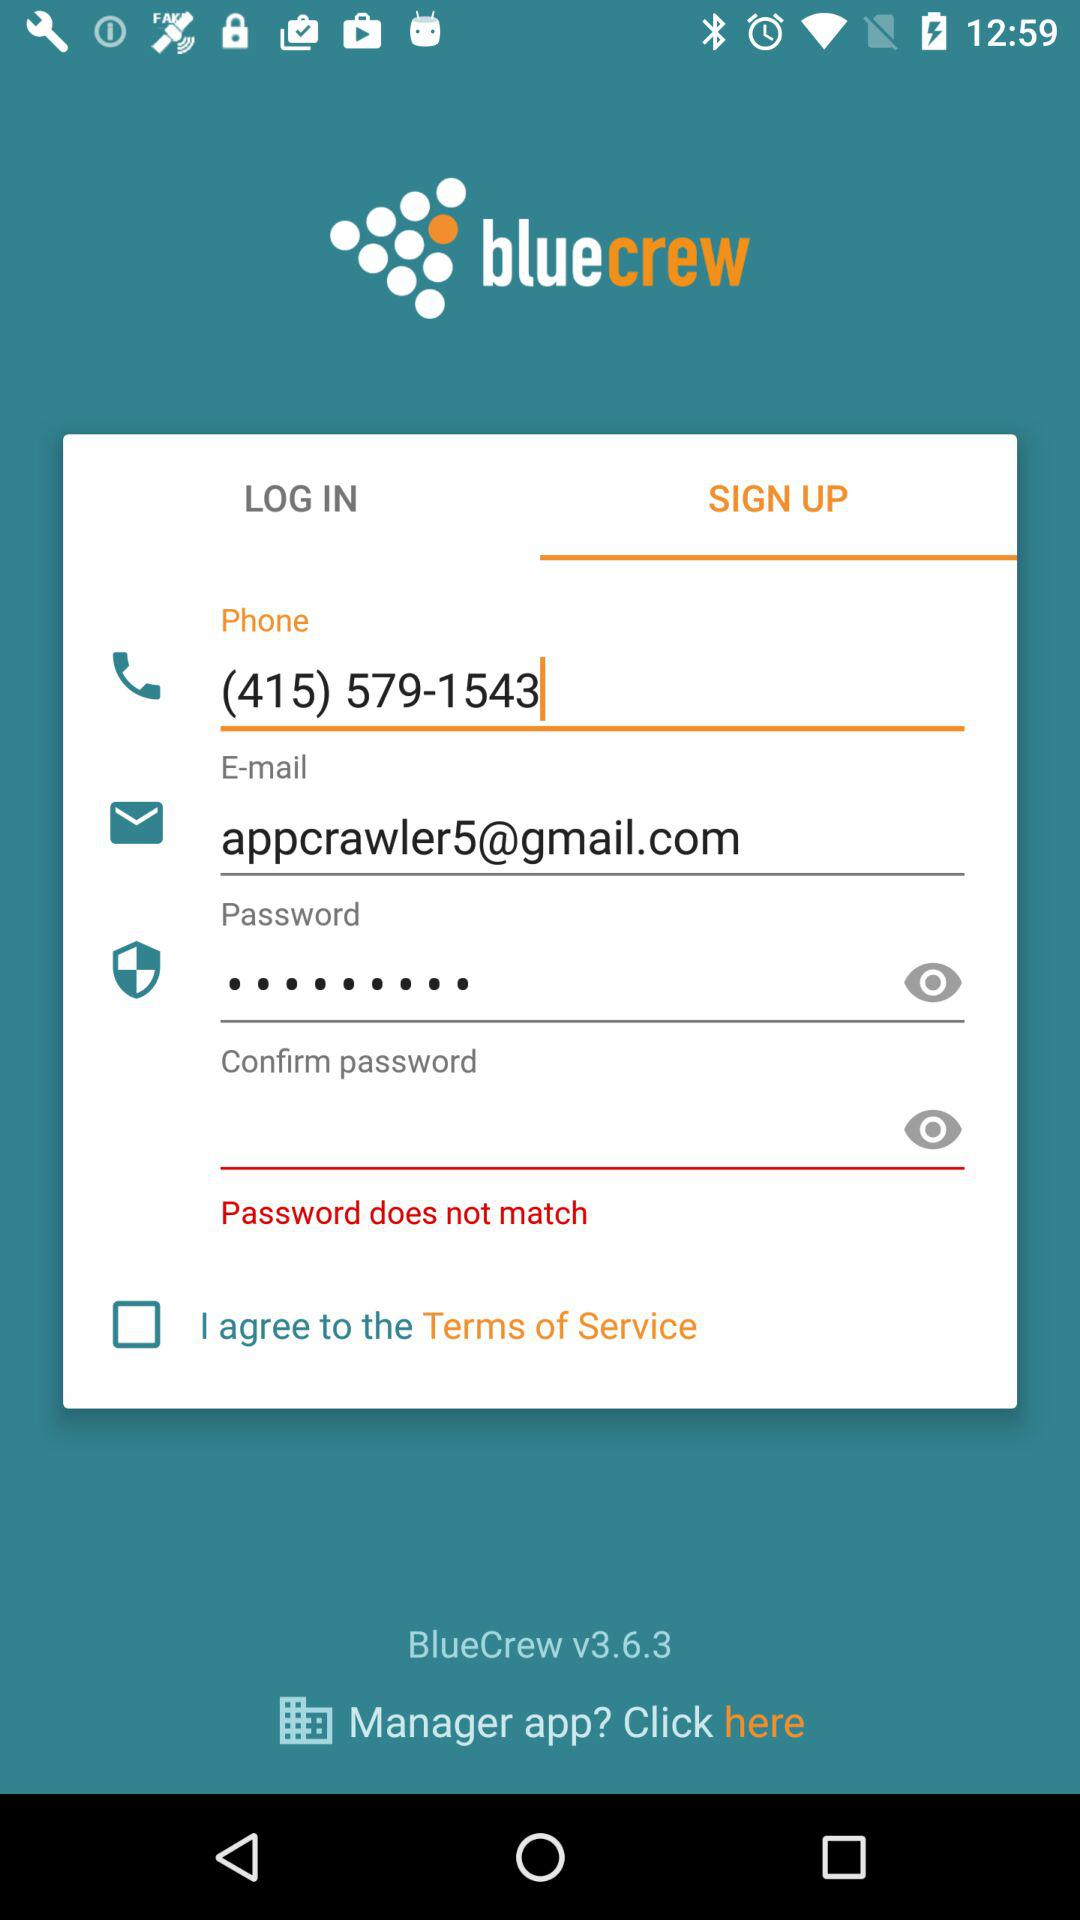What is the email address? The email address is appcrawler5@gmail.com. 